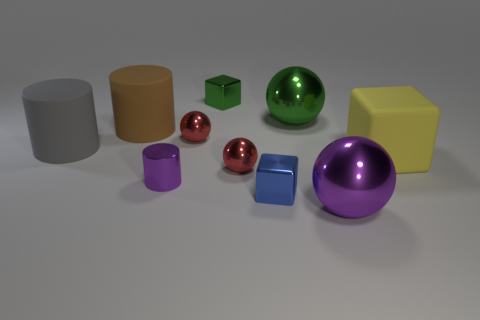Subtract 1 spheres. How many spheres are left? 3 Subtract all cubes. How many objects are left? 7 Add 5 big green rubber objects. How many big green rubber objects exist? 5 Subtract 0 green cylinders. How many objects are left? 10 Subtract all big yellow shiny objects. Subtract all small cylinders. How many objects are left? 9 Add 9 tiny purple things. How many tiny purple things are left? 10 